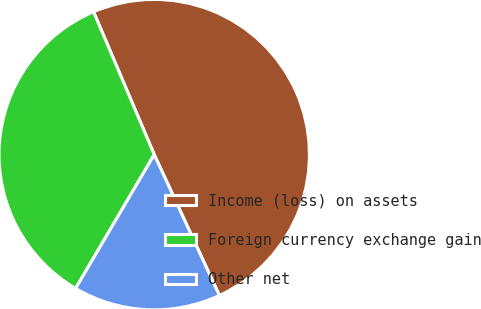Convert chart. <chart><loc_0><loc_0><loc_500><loc_500><pie_chart><fcel>Income (loss) on assets<fcel>Foreign currency exchange gain<fcel>Other net<nl><fcel>49.5%<fcel>35.15%<fcel>15.35%<nl></chart> 